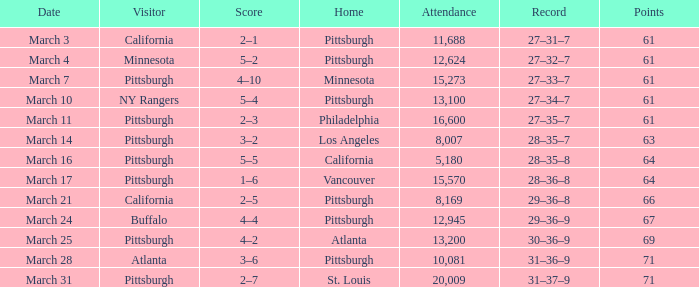What is the total for the pittsburgh home contest on march 3 with 61 points? 2–1. 